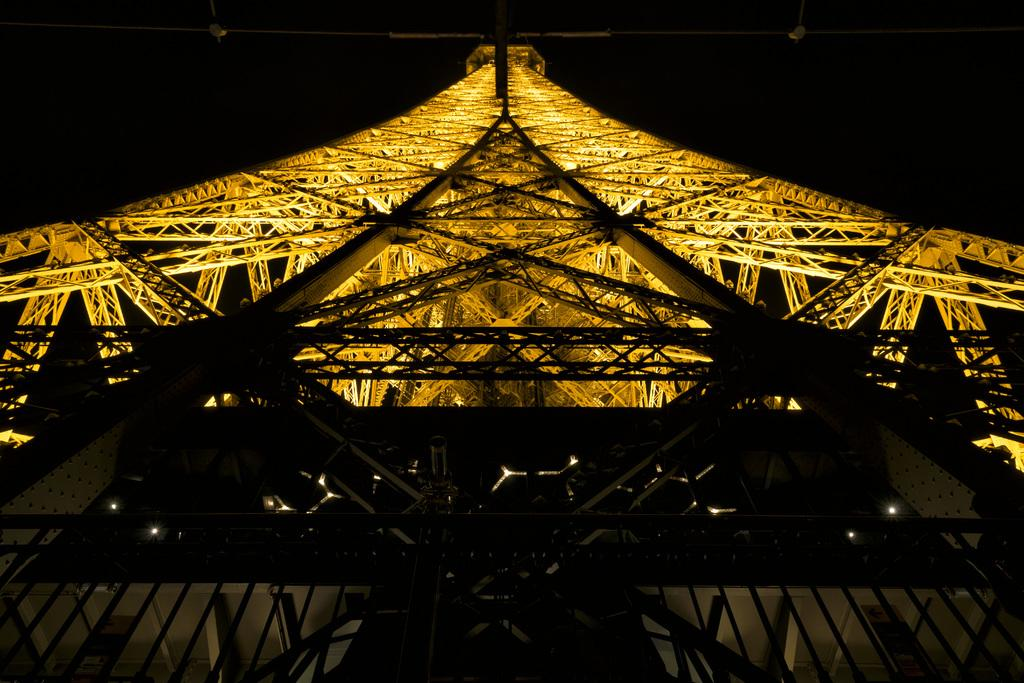What is the main structure in the image? There is a tower in the image. What can be seen illuminated in the image? There are lights visible in the image. What type of polish is the queen applying to her nails in the image? There is no queen or any indication of nail polish in the image. 